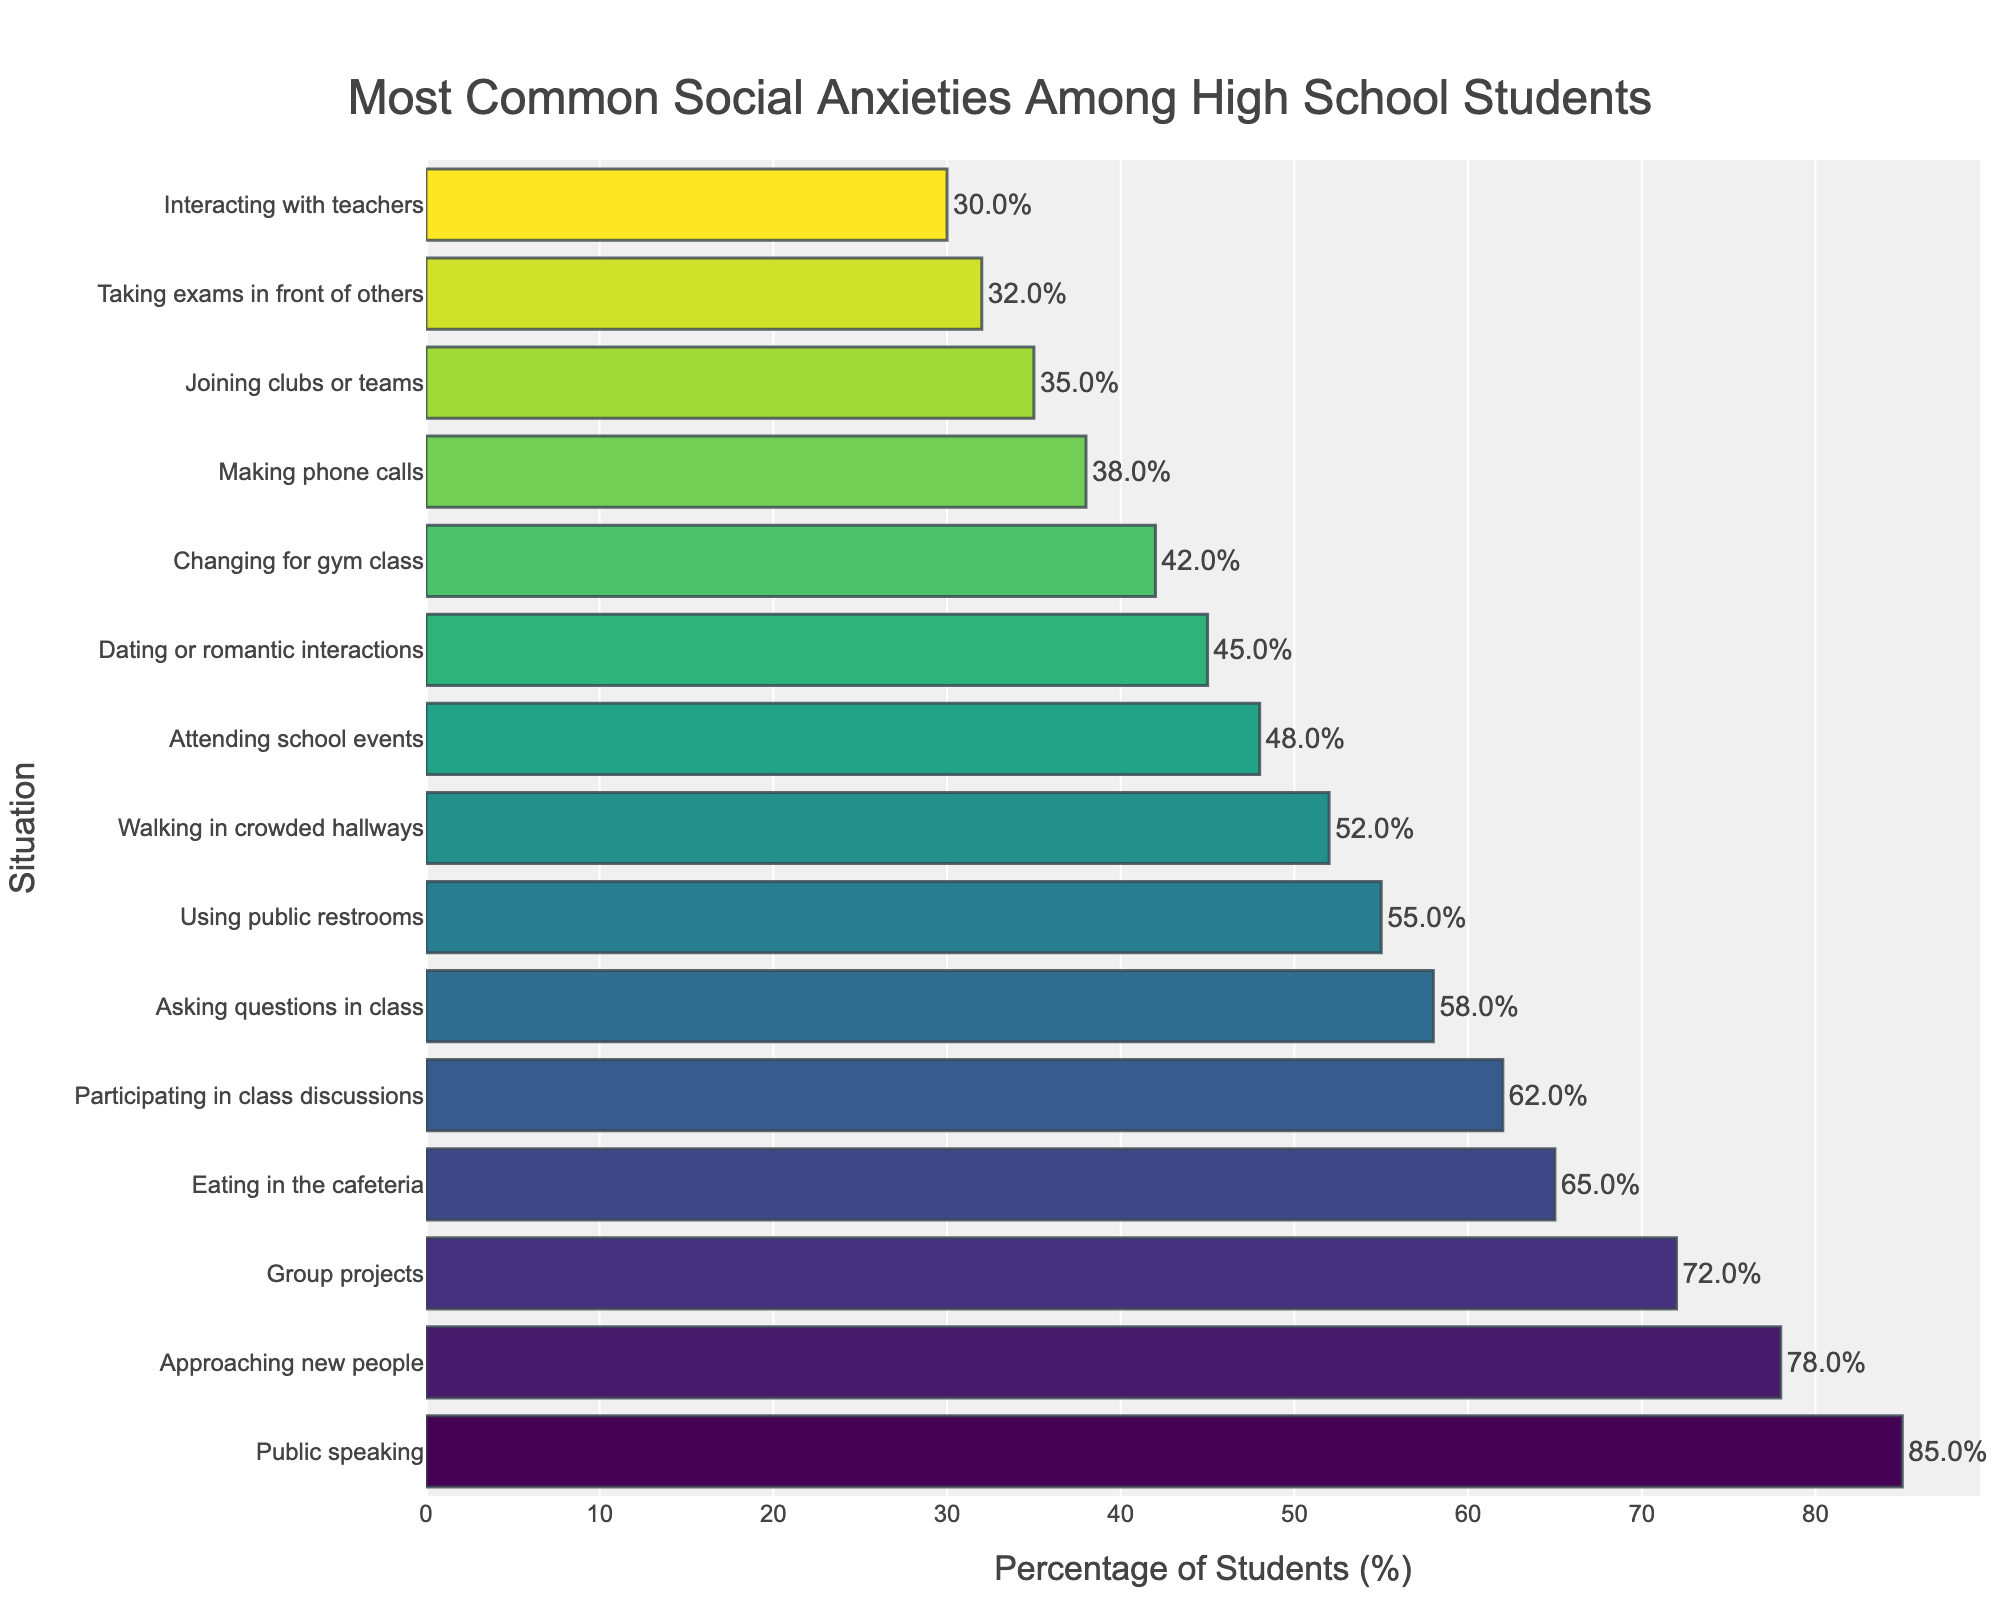Which situation has the highest percentage of social anxiety among high school students? By looking at the figure, you can identify the bar that extends the furthest to the right, indicating the highest percentage. This bar corresponds to "Public speaking."
Answer: Public speaking How much higher is the percentage of students anxious about public speaking compared to those anxious about changing for gym class? First, find the percentages for both "Public speaking" (85%) and "Changing for gym class" (42%). Then, subtract the smaller percentage from the larger one: 85% - 42% = 43%.
Answer: 43% Which two situations have the closest percentages of social anxiety, and what are they? Compare the percentages for all situations. "Walking in crowded hallways" (52%) and "Using public restrooms" (55%) have a difference of just 3 percentage points, which is the smallest difference.
Answer: Walking in crowded hallways and Using public restrooms What is the combined percentage of students who feel anxious about participating in class discussions and joining clubs or teams? Find the percentages for both conditions (62% for "Participating in class discussions" and 35% for "Joining clubs or teams"), then add them: 62% + 35% = 97%.
Answer: 97% Which type of social anxiety is least common among high school students? Look at the bar with the smallest extension to the right. This corresponds to "Interacting with teachers," which has the lowest percentage.
Answer: Interacting with teachers Is the percentage of students anxious about dating or romantic interactions greater than or less than the percentage of students anxious about eating in the cafeteria? Compare the two percentages: 45% for "Dating or romantic interactions" and 65% for "Eating in the cafeteria." Since 45% is less than 65%, dating or romantic interactions have a smaller percentage.
Answer: Less than What is the average percentage of the three most common social anxieties? First identify the three highest percentages: "Public speaking" (85%), "Approaching new people" (78%), and "Group projects" (72%). Then calculate the average: (85% + 78% + 72%) / 3 = 78.33%.
Answer: 78.33% How does the percentage of students anxious about making phone calls compare with those anxious about using public restrooms? Find the percentages for both situations: 38% for "Making phone calls" and 55% for "Using public restrooms." Since 38% is less than 55%, making phone calls has a smaller percentage.
Answer: Smaller than 